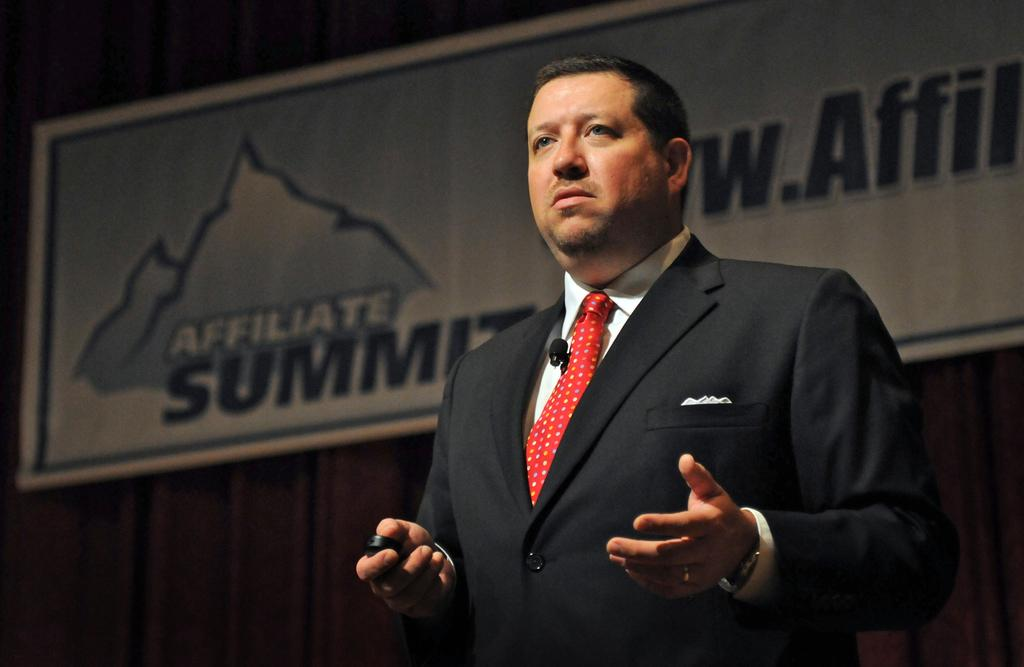Who is the main subject in the image? There is a man standing in the center of the image. What is the man wearing? The man is wearing a suit. What can be seen in the background of the image? There is a board and a curtain in the background of the image. How many eggs are on the board in the image? There are no eggs visible in the image; only a board and a curtain can be seen in the background. 